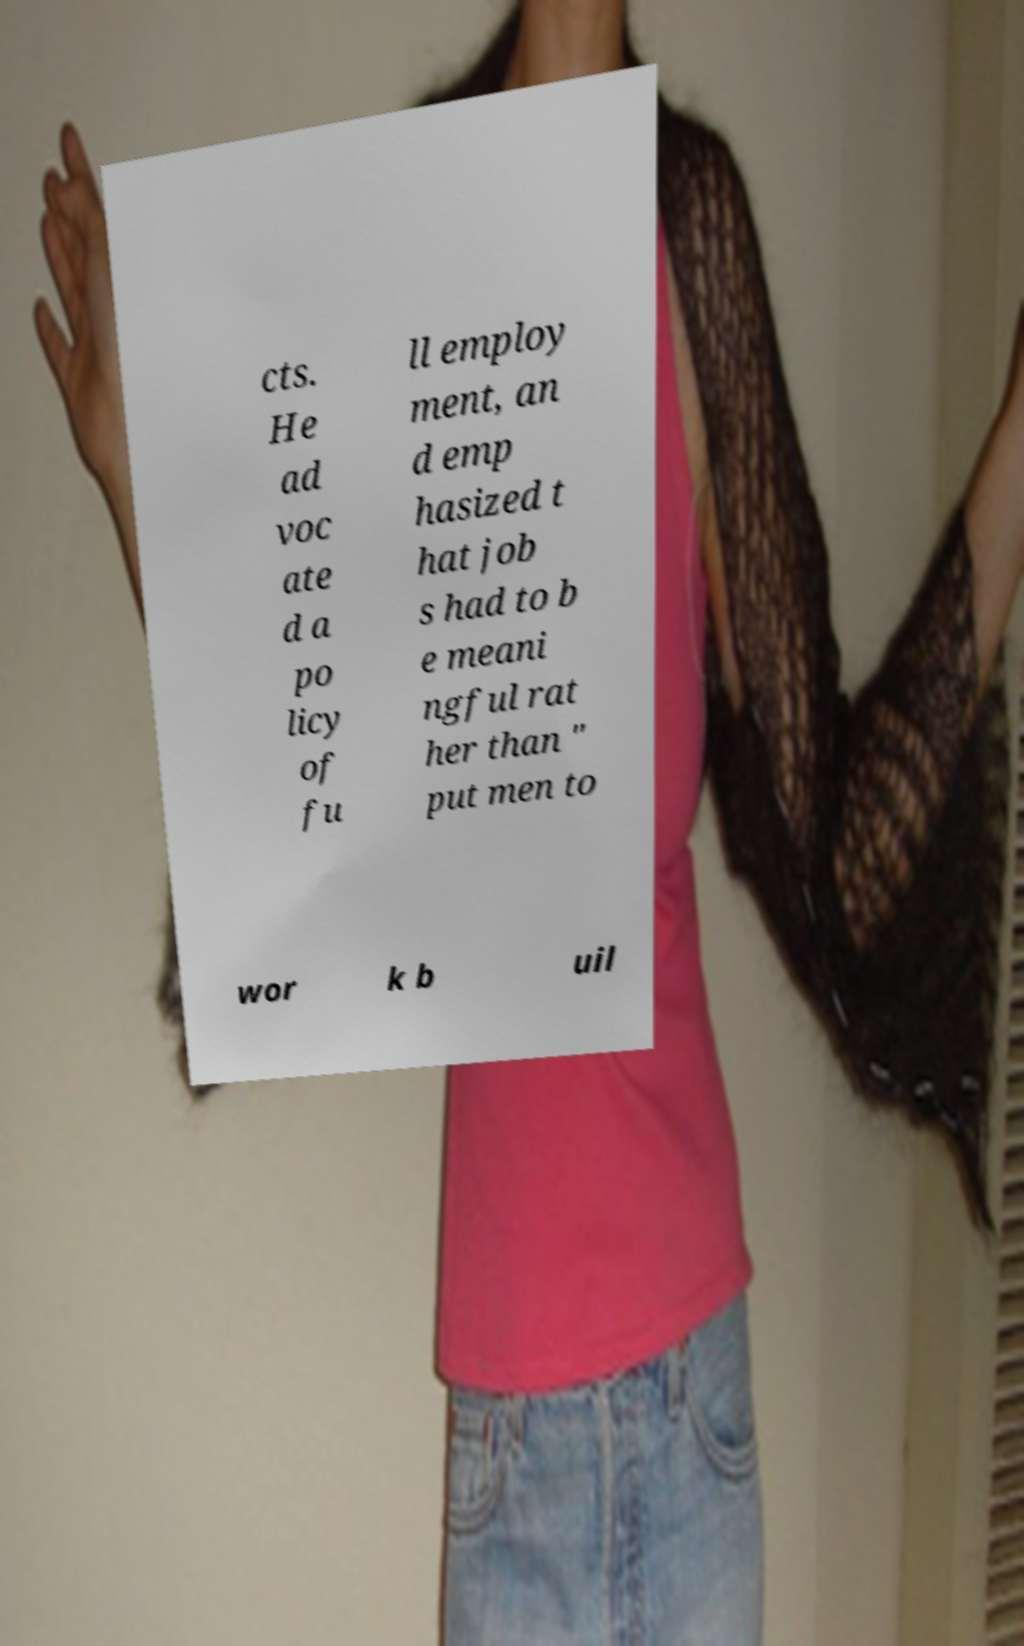Please identify and transcribe the text found in this image. cts. He ad voc ate d a po licy of fu ll employ ment, an d emp hasized t hat job s had to b e meani ngful rat her than " put men to wor k b uil 